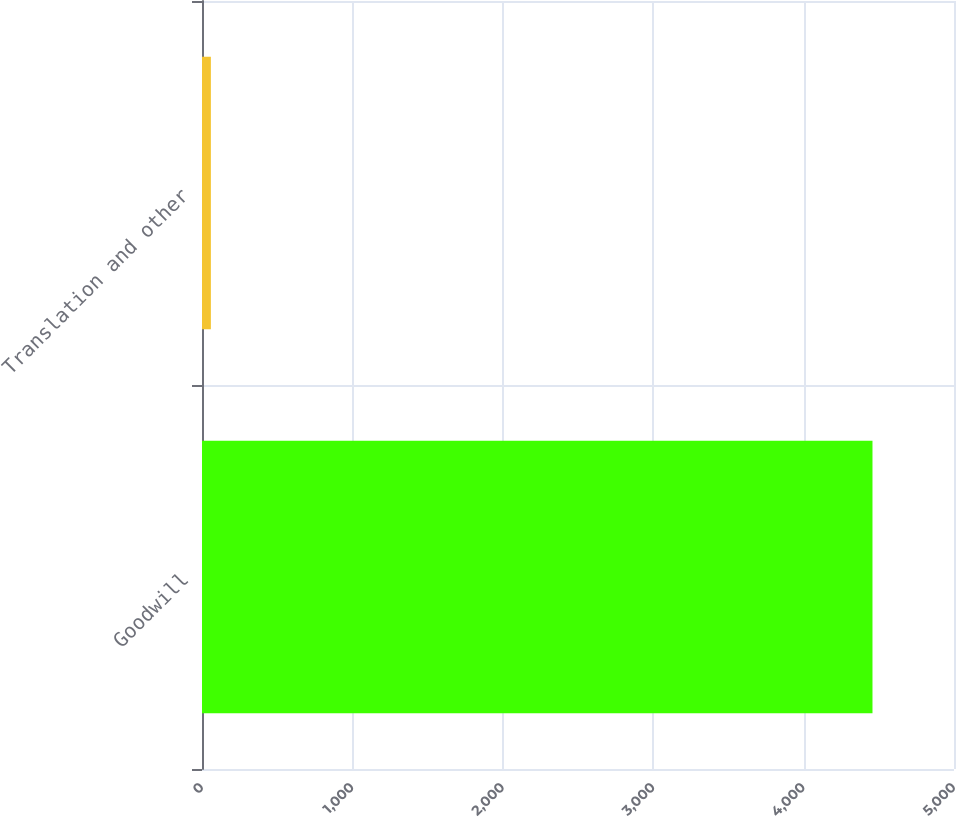<chart> <loc_0><loc_0><loc_500><loc_500><bar_chart><fcel>Goodwill<fcel>Translation and other<nl><fcel>4458<fcel>59<nl></chart> 